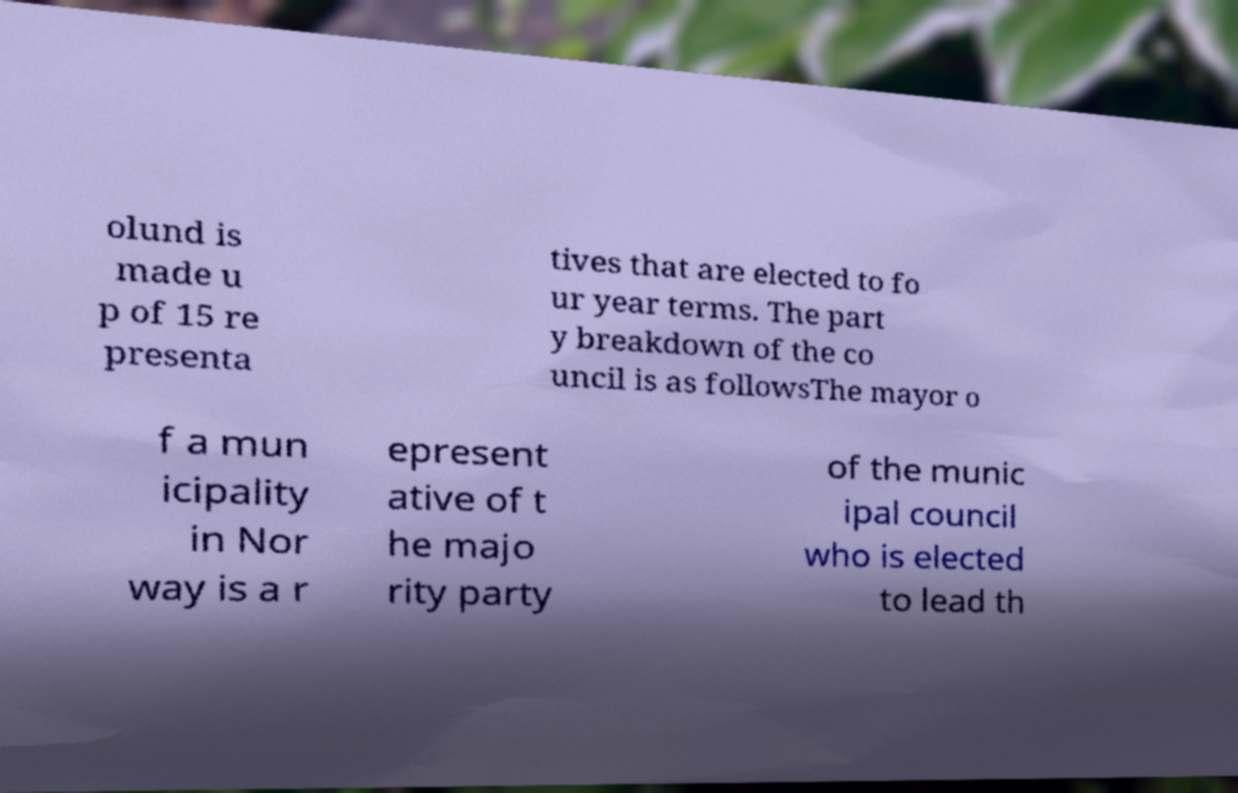Please identify and transcribe the text found in this image. olund is made u p of 15 re presenta tives that are elected to fo ur year terms. The part y breakdown of the co uncil is as followsThe mayor o f a mun icipality in Nor way is a r epresent ative of t he majo rity party of the munic ipal council who is elected to lead th 